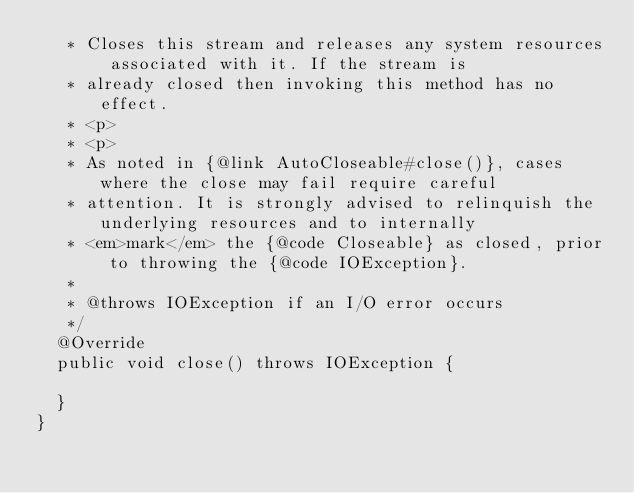Convert code to text. <code><loc_0><loc_0><loc_500><loc_500><_Java_>   * Closes this stream and releases any system resources associated with it. If the stream is
   * already closed then invoking this method has no effect.
   * <p>
   * <p>
   * As noted in {@link AutoCloseable#close()}, cases where the close may fail require careful
   * attention. It is strongly advised to relinquish the underlying resources and to internally
   * <em>mark</em> the {@code Closeable} as closed, prior to throwing the {@code IOException}.
   * 
   * @throws IOException if an I/O error occurs
   */
  @Override
  public void close() throws IOException {

  }
}
</code> 